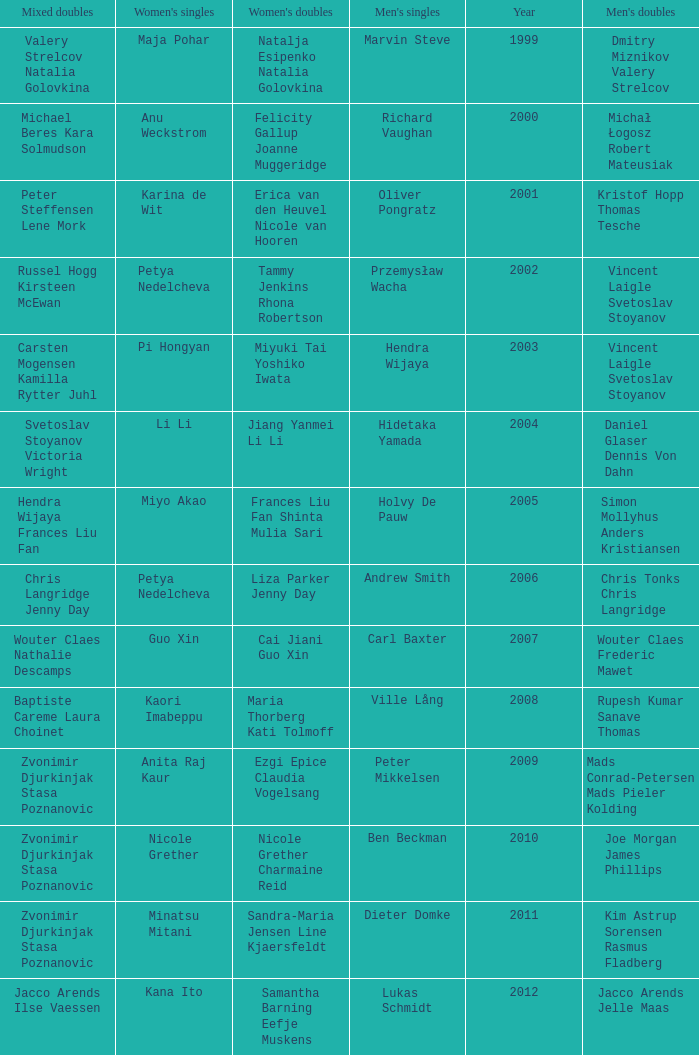What's the first year that Guo Xin featured in women's singles? 2007.0. Write the full table. {'header': ['Mixed doubles', "Women's singles", "Women's doubles", "Men's singles", 'Year', "Men's doubles"], 'rows': [['Valery Strelcov Natalia Golovkina', 'Maja Pohar', 'Natalja Esipenko Natalia Golovkina', 'Marvin Steve', '1999', 'Dmitry Miznikov Valery Strelcov'], ['Michael Beres Kara Solmudson', 'Anu Weckstrom', 'Felicity Gallup Joanne Muggeridge', 'Richard Vaughan', '2000', 'Michał Łogosz Robert Mateusiak'], ['Peter Steffensen Lene Mork', 'Karina de Wit', 'Erica van den Heuvel Nicole van Hooren', 'Oliver Pongratz', '2001', 'Kristof Hopp Thomas Tesche'], ['Russel Hogg Kirsteen McEwan', 'Petya Nedelcheva', 'Tammy Jenkins Rhona Robertson', 'Przemysław Wacha', '2002', 'Vincent Laigle Svetoslav Stoyanov'], ['Carsten Mogensen Kamilla Rytter Juhl', 'Pi Hongyan', 'Miyuki Tai Yoshiko Iwata', 'Hendra Wijaya', '2003', 'Vincent Laigle Svetoslav Stoyanov'], ['Svetoslav Stoyanov Victoria Wright', 'Li Li', 'Jiang Yanmei Li Li', 'Hidetaka Yamada', '2004', 'Daniel Glaser Dennis Von Dahn'], ['Hendra Wijaya Frances Liu Fan', 'Miyo Akao', 'Frances Liu Fan Shinta Mulia Sari', 'Holvy De Pauw', '2005', 'Simon Mollyhus Anders Kristiansen'], ['Chris Langridge Jenny Day', 'Petya Nedelcheva', 'Liza Parker Jenny Day', 'Andrew Smith', '2006', 'Chris Tonks Chris Langridge'], ['Wouter Claes Nathalie Descamps', 'Guo Xin', 'Cai Jiani Guo Xin', 'Carl Baxter', '2007', 'Wouter Claes Frederic Mawet'], ['Baptiste Careme Laura Choinet', 'Kaori Imabeppu', 'Maria Thorberg Kati Tolmoff', 'Ville Lång', '2008', 'Rupesh Kumar Sanave Thomas'], ['Zvonimir Djurkinjak Stasa Poznanovic', 'Anita Raj Kaur', 'Ezgi Epice Claudia Vogelsang', 'Peter Mikkelsen', '2009', 'Mads Conrad-Petersen Mads Pieler Kolding'], ['Zvonimir Djurkinjak Stasa Poznanovic', 'Nicole Grether', 'Nicole Grether Charmaine Reid', 'Ben Beckman', '2010', 'Joe Morgan James Phillips'], ['Zvonimir Djurkinjak Stasa Poznanovic', 'Minatsu Mitani', 'Sandra-Maria Jensen Line Kjaersfeldt', 'Dieter Domke', '2011', 'Kim Astrup Sorensen Rasmus Fladberg'], ['Jacco Arends Ilse Vaessen', 'Kana Ito', 'Samantha Barning Eefje Muskens', 'Lukas Schmidt', '2012', 'Jacco Arends Jelle Maas']]} 